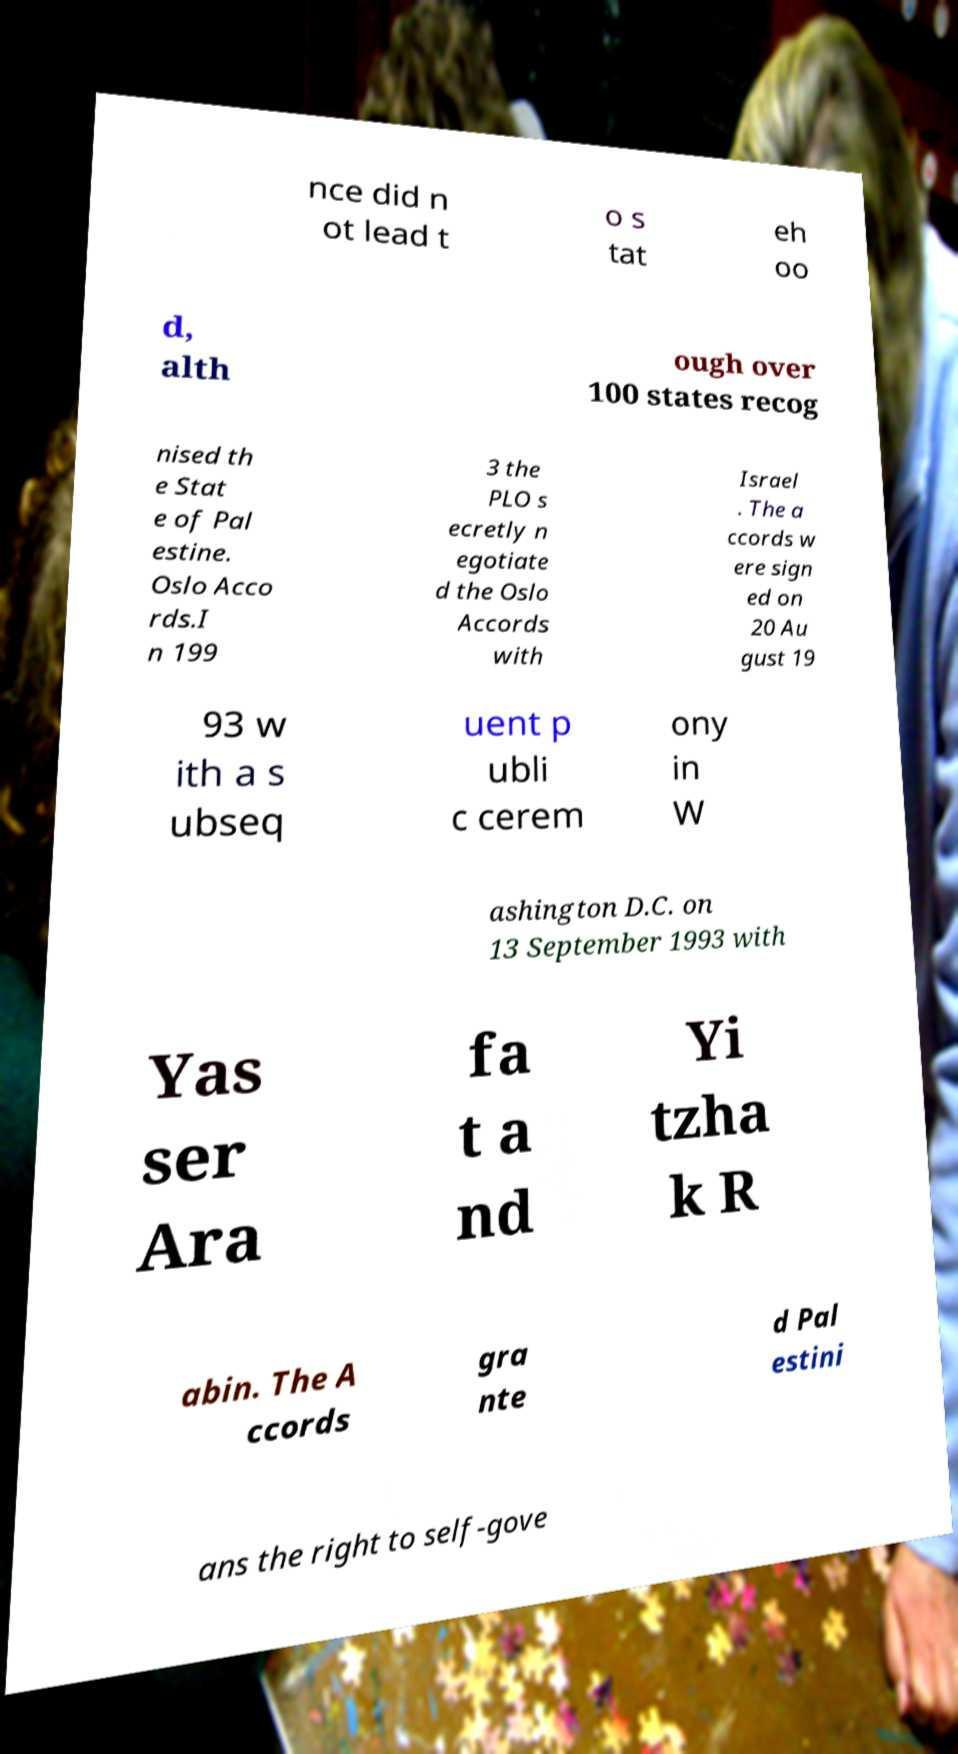Can you accurately transcribe the text from the provided image for me? nce did n ot lead t o s tat eh oo d, alth ough over 100 states recog nised th e Stat e of Pal estine. Oslo Acco rds.I n 199 3 the PLO s ecretly n egotiate d the Oslo Accords with Israel . The a ccords w ere sign ed on 20 Au gust 19 93 w ith a s ubseq uent p ubli c cerem ony in W ashington D.C. on 13 September 1993 with Yas ser Ara fa t a nd Yi tzha k R abin. The A ccords gra nte d Pal estini ans the right to self-gove 